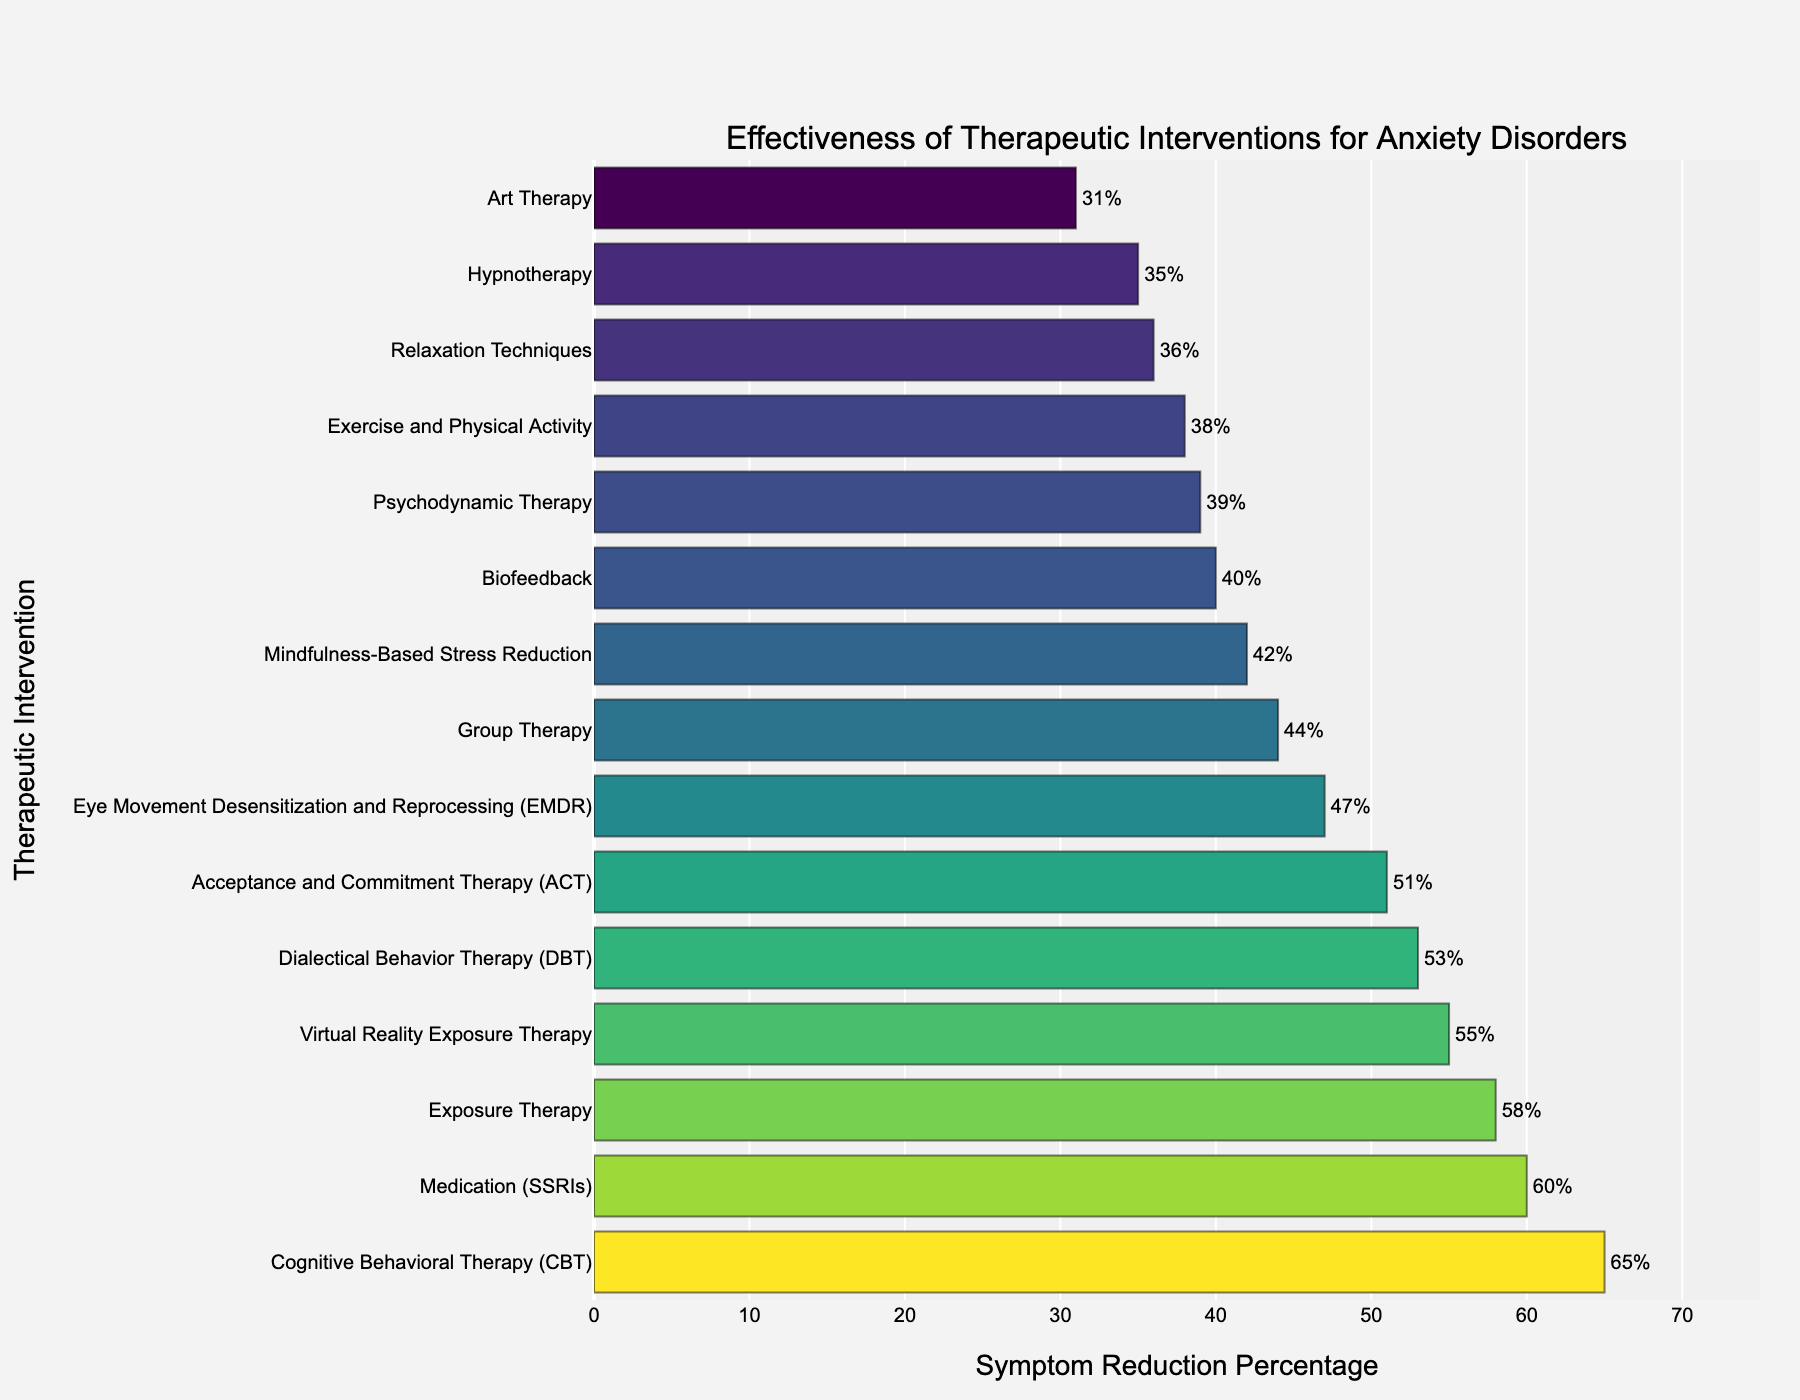What's the most effective therapeutic intervention for anxiety disorders based on the figure? The tallest bar in the figure represents the highest symptom reduction percentage. Cognitive Behavioral Therapy (CBT) has the tallest bar, indicating it is the most effective.
Answer: Cognitive Behavioral Therapy (CBT) Which interventions have a symptom reduction percentage of 40% or less? By looking at the bar lengths and their associated labels, we can see that Art Therapy (31%), Relaxation Techniques (36%), Hypnotherapy (35%), Biofeedback (40%), Psychodynamic Therapy (39%), and Exercise and Physical Activity (38%) fall at or below 40%.
Answer: Art Therapy, Relaxation Techniques, Hypnotherapy, Biofeedback, Psychodynamic Therapy, Exercise, and Physical Activity How much more effective is CBT compared to Art Therapy? The bar for CBT shows 65% symptom reduction, while Art Therapy shows 31%. The difference between them is 65% - 31% = 34%.
Answer: 34% Which interventions have a slightly over 50% symptom reduction and by how much? By looking at the figure, we can see that Acceptance and Commitment Therapy (ACT) has 51%, Dialectical Behavior Therapy (DBT) has 53%, and Virtual Reality Exposure Therapy has 55%. For each, we calculate the difference from 50%: ACT is 1% above, DBT is 3% above, and Virtual Reality Exposure Therapy is 5% above.
Answer: ACT by 1%, DBT by 3%, Virtual Reality Exposure Therapy by 5% What is the average symptom reduction percentage for all the interventions shown? Sum all the percentages and divide by the number of interventions: (65 + 58 + 42 + 51 + 39 + 47 + 53 + 60 + 35 + 55 + 31 + 44 + 38 + 40 + 36) / 15 = 694 / 15 = 46.27%.
Answer: 46.27% Which therapeutic interventions are more effective than SSRI medication (60%)? Interventions above the bar labeled SSRIs (60%) are Cognitive Behavioral Therapy (65%).
Answer: Cognitive Behavioral Therapy (CBT) How many interventions have a symptom reduction percentage between 35% and 50%? By observing the bars within this range: Mindfulness-Based Stress Reduction (42%), Acceptance and Commitment Therapy (51%), Psychodynamic Therapy (39%), Eye Movement Desensitization and Reprocessing (47%), and Group Therapy (44%). This makes 5 interventions.
Answer: 5 Which therapy is least effective and what percentage reduction does it have? The shortest bar in the figure represents the lowest symptom reduction percentage, which is Art Therapy at 31%.
Answer: Art Therapy, 31% What is the difference in symptom reduction between Exposure Therapy and Hypnotherapy? Exposure Therapy has a symptom reduction of 58%, and Hypnotherapy has 35%. The difference is 58% - 35% = 23%.
Answer: 23% Are there any interventions with exactly 47% symptom reduction? If so, which ones? By examining the figure, the bar for Eye Movement Desensitization and Reprocessing (EMDR) shows exactly 47%.
Answer: Yes, Eye Movement Desensitization and Reprocessing (EMDR) 